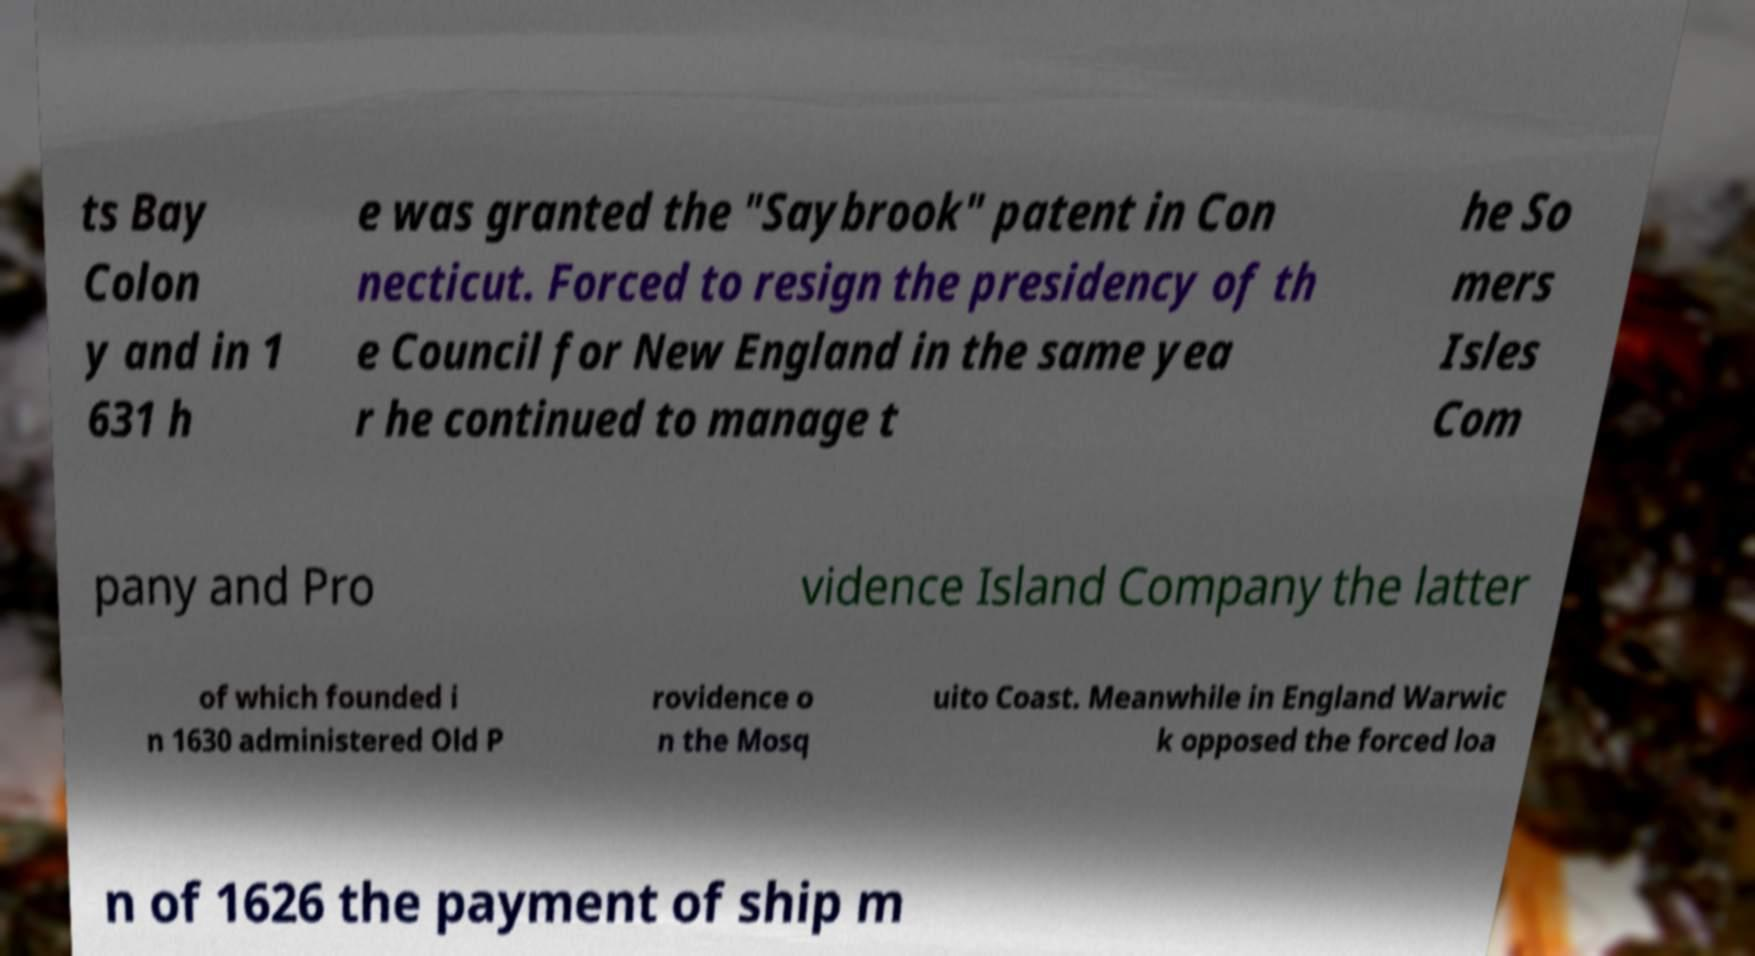There's text embedded in this image that I need extracted. Can you transcribe it verbatim? ts Bay Colon y and in 1 631 h e was granted the "Saybrook" patent in Con necticut. Forced to resign the presidency of th e Council for New England in the same yea r he continued to manage t he So mers Isles Com pany and Pro vidence Island Company the latter of which founded i n 1630 administered Old P rovidence o n the Mosq uito Coast. Meanwhile in England Warwic k opposed the forced loa n of 1626 the payment of ship m 